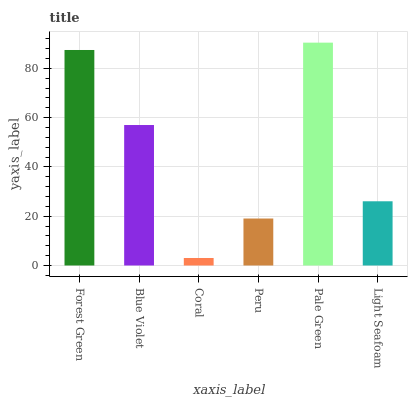Is Blue Violet the minimum?
Answer yes or no. No. Is Blue Violet the maximum?
Answer yes or no. No. Is Forest Green greater than Blue Violet?
Answer yes or no. Yes. Is Blue Violet less than Forest Green?
Answer yes or no. Yes. Is Blue Violet greater than Forest Green?
Answer yes or no. No. Is Forest Green less than Blue Violet?
Answer yes or no. No. Is Blue Violet the high median?
Answer yes or no. Yes. Is Light Seafoam the low median?
Answer yes or no. Yes. Is Forest Green the high median?
Answer yes or no. No. Is Forest Green the low median?
Answer yes or no. No. 